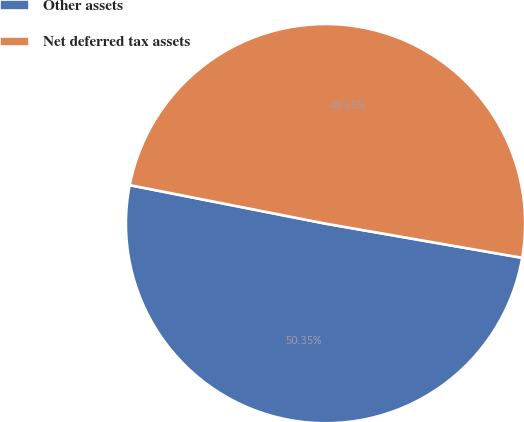Convert chart. <chart><loc_0><loc_0><loc_500><loc_500><pie_chart><fcel>Other assets<fcel>Net deferred tax assets<nl><fcel>50.35%<fcel>49.65%<nl></chart> 